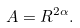<formula> <loc_0><loc_0><loc_500><loc_500>A = R ^ { 2 \alpha } .</formula> 